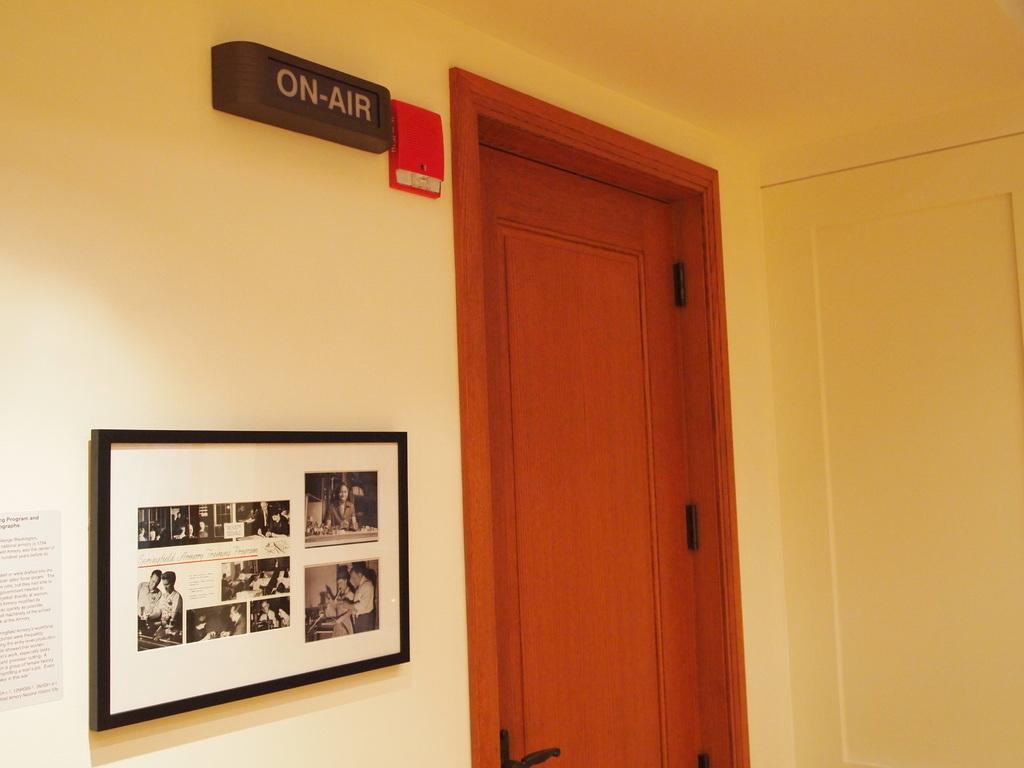What is the main object in the image? There is a frame in the image. What is inside the frame? There is a paper with text in the image. How many objects are hanging on the wall? Two objects are hanging on the wall. Can you describe the door in the image? There is a door in the image. What color are the horse's eyes in the image? There is no horse present in the image, so it is not possible to determine the color of its eyes. 